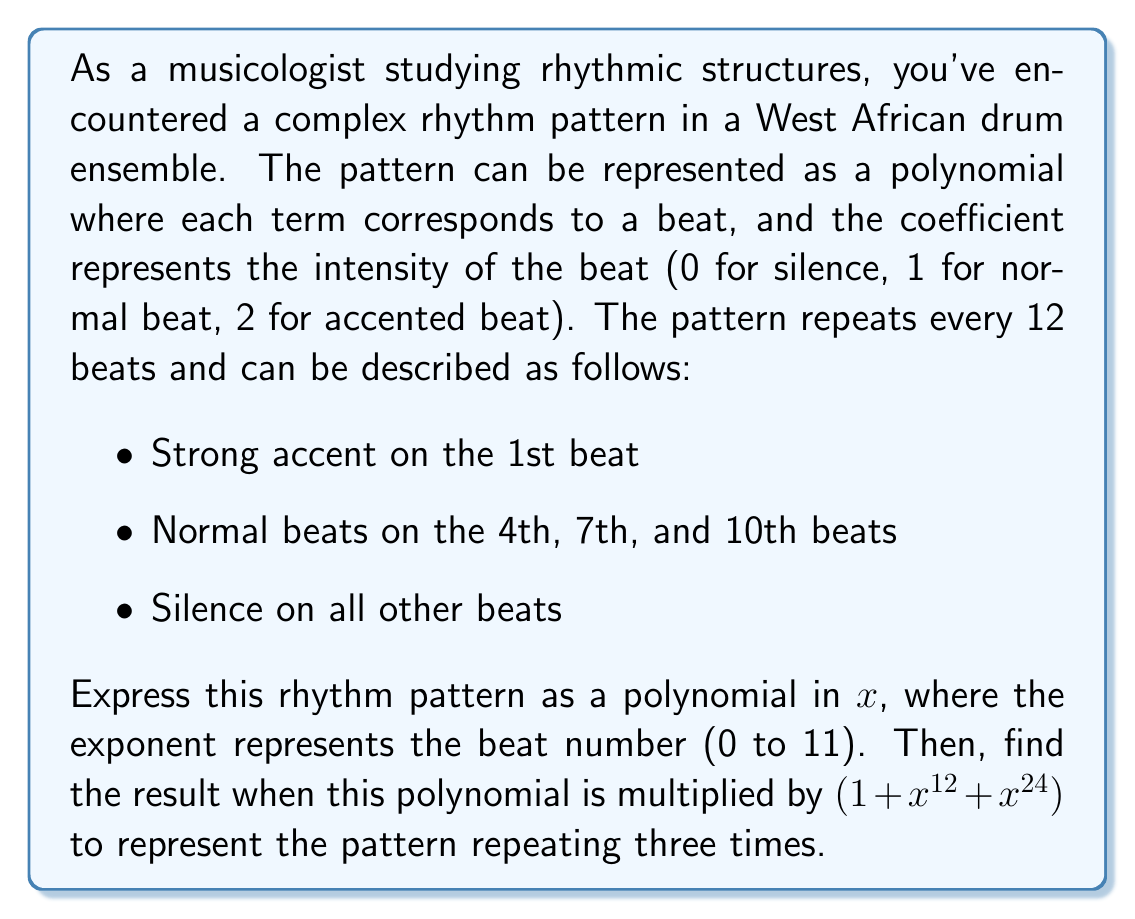Teach me how to tackle this problem. Let's approach this step-by-step:

1) First, we need to express the rhythm pattern as a polynomial. Each term will be in the form $ax^n$ where:
   - $a$ is the intensity (0, 1, or 2)
   - $n$ is the beat number (0 to 11)

   The polynomial will be:

   $P(x) = 2x^0 + x^3 + x^6 + x^9$

2) Now, we need to multiply this polynomial by $(1 + x^{12} + x^{24})$. This operation represents repeating the pattern three times.

3) Let's distribute $P(x)$ over each term:

   $P(x)(1 + x^{12} + x^{24}) = P(x) + P(x)x^{12} + P(x)x^{24}$

4) Expanding this:

   $(2x^0 + x^3 + x^6 + x^9) + (2x^{12} + x^{15} + x^{18} + x^{21}) + (2x^{24} + x^{27} + x^{30} + x^{33})$

5) Simplifying and combining like terms:

   $2 + x^3 + x^6 + x^9 + 2x^{12} + x^{15} + x^{18} + x^{21} + 2x^{24} + x^{27} + x^{30} + x^{33}$

This final polynomial represents the rhythm pattern repeated three times over 36 beats.
Answer: $2 + x^3 + x^6 + x^9 + 2x^{12} + x^{15} + x^{18} + x^{21} + 2x^{24} + x^{27} + x^{30} + x^{33}$ 